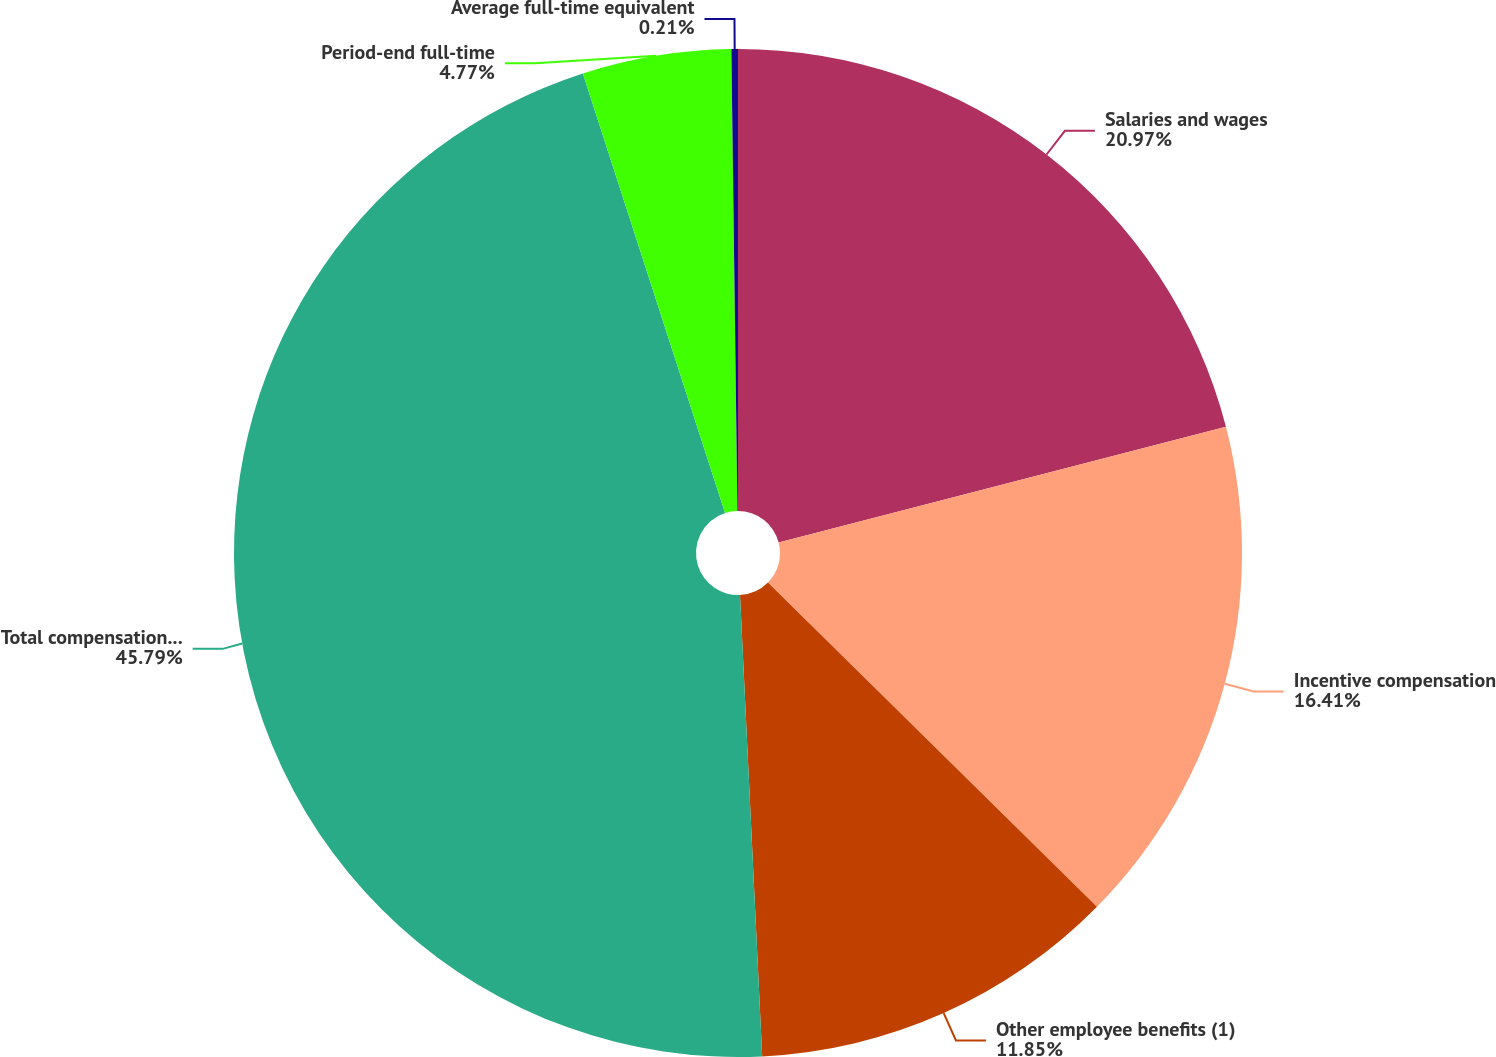Convert chart to OTSL. <chart><loc_0><loc_0><loc_500><loc_500><pie_chart><fcel>Salaries and wages<fcel>Incentive compensation<fcel>Other employee benefits (1)<fcel>Total compensation and<fcel>Period-end full-time<fcel>Average full-time equivalent<nl><fcel>20.97%<fcel>16.41%<fcel>11.85%<fcel>45.78%<fcel>4.77%<fcel>0.21%<nl></chart> 